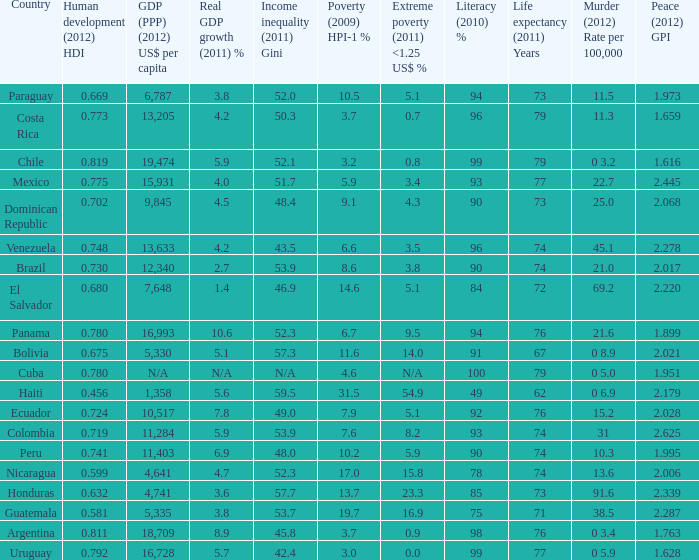What is the total poverty (2009) HPI-1 % when the extreme poverty (2011) <1.25 US$ % of 16.9, and the human development (2012) HDI is less than 0.581? None. 